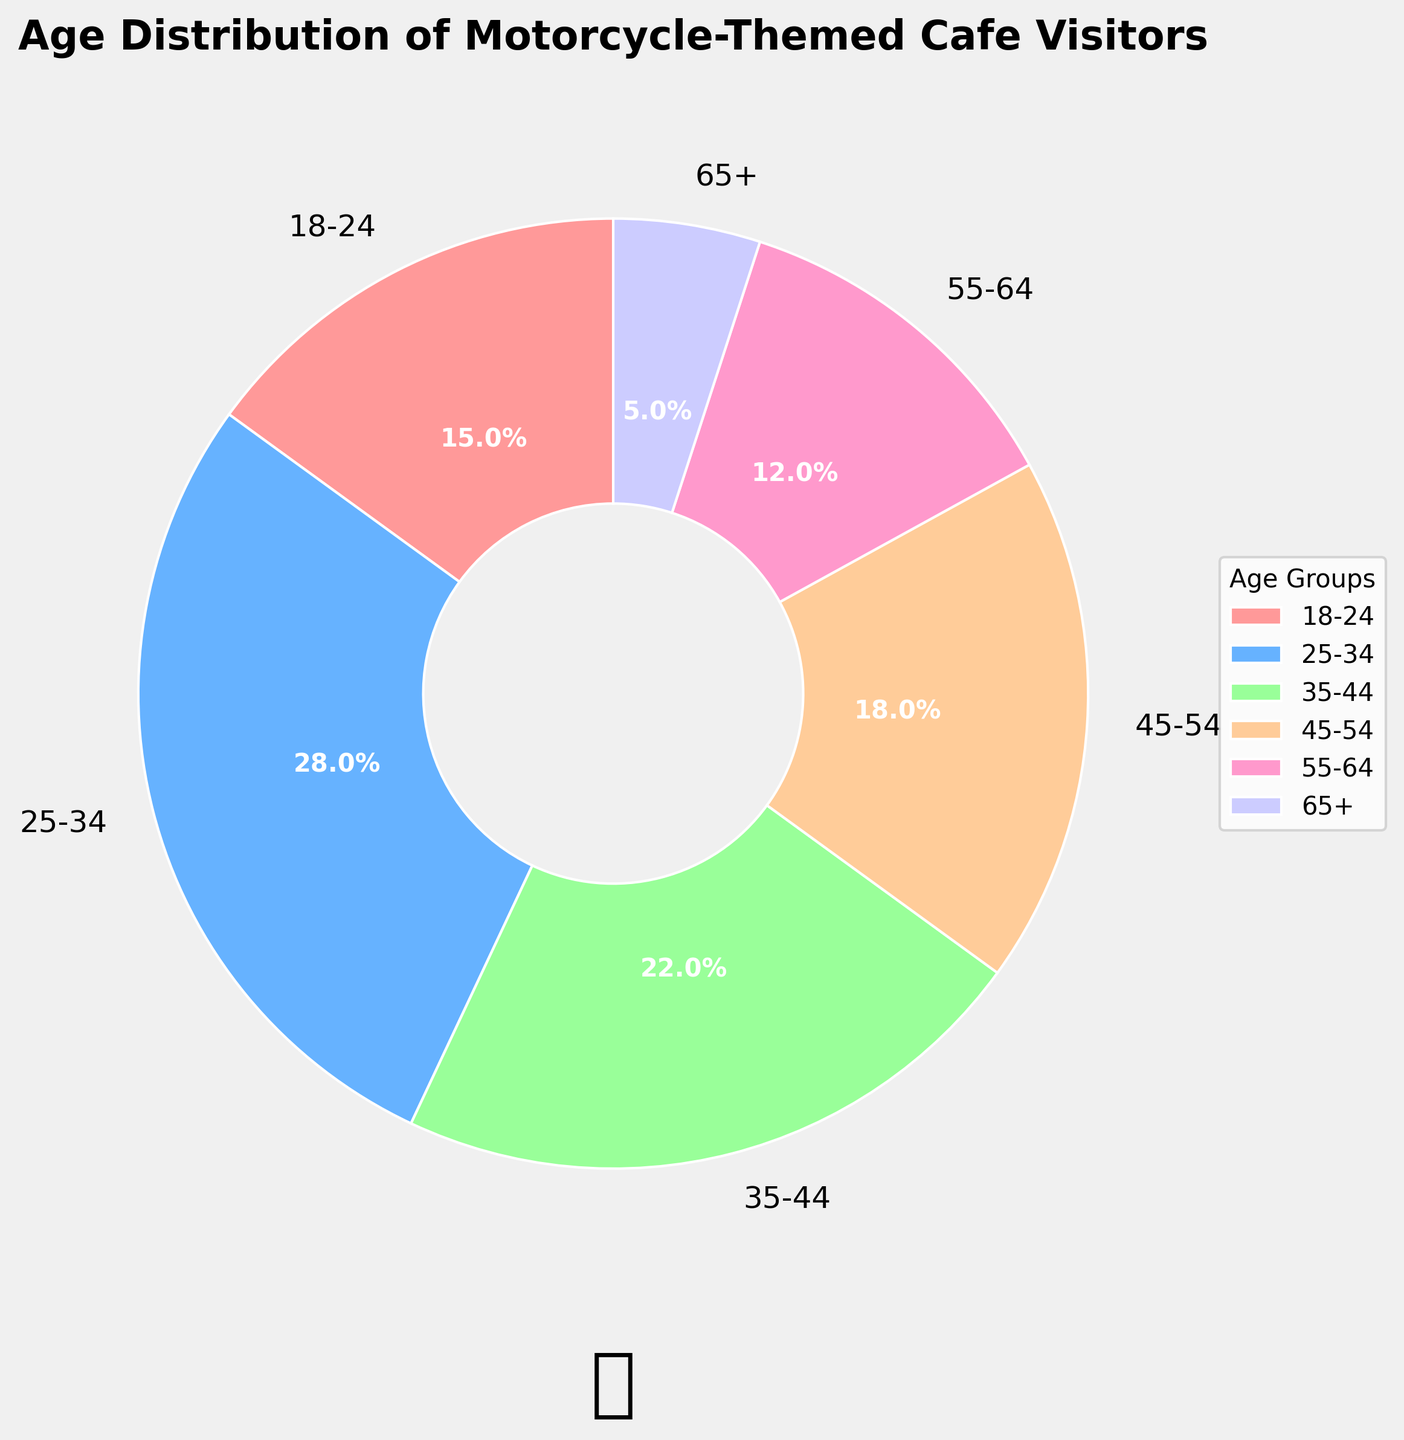What percentage of visitors are aged 25-34? Locate the age group "25-34" on the pie chart and look at the associated percentage.
Answer: 28% Which age group has the smallest percentage of visitors? Find the smallest slice in the pie chart and check the corresponding age group.
Answer: 65+ How many age groups constitute more than 20% of the visitors each? Identify the segments with percentages greater than 20%. Both "25-34" and "35-44" fulfill this condition.
Answer: 2 What is the sum of the percentages for age groups 45-54 and 55-64? Locate the percentages for age groups "45-54" (18%) and "55-64" (12%). Add these percentages: 18 + 12 = 30.
Answer: 30% What is the ratio of visitors aged 18-24 to visitors aged 55-64? Identify the percentages for age groups "18-24" (15%) and "55-64" (12%). Divide 15 by 12 to get the ratio: 15 / 12 ≈ 1.25.
Answer: 1.25 Which age group is represented by the blue slice in the pie chart? Visually locate the blue-colored segment on the chart. The blue color corresponds to "25-34."
Answer: 25-34 Do more visitors belong to the age group 45-54 or 35-44? Compare the percentages for "45-54" (18%) and "35-44" (22%). 22% is greater than 18%.
Answer: 35-44 If the percentages for the age groups 18-24 and 65+ are combined, do they exceed the percentage for the 25-34 age group? Identify the percentages for age groups "18-24" (15%) and "65+" (5%). Add these percentages: 15 + 5 = 20. Compare with "25-34" (28%). 20% is less than 28%.
Answer: No Which age group has the largest number of visitors? Identify the largest segment in the pie chart, which corresponds to the age group "25-34."
Answer: 25-34 How much greater is the percentage of visitors aged 35-44 compared to those aged 55-64? Subtract the percentage of the age group "55-64" (12%) from that of the age group "35-44" (22%). The difference is 22 - 12 = 10.
Answer: 10 